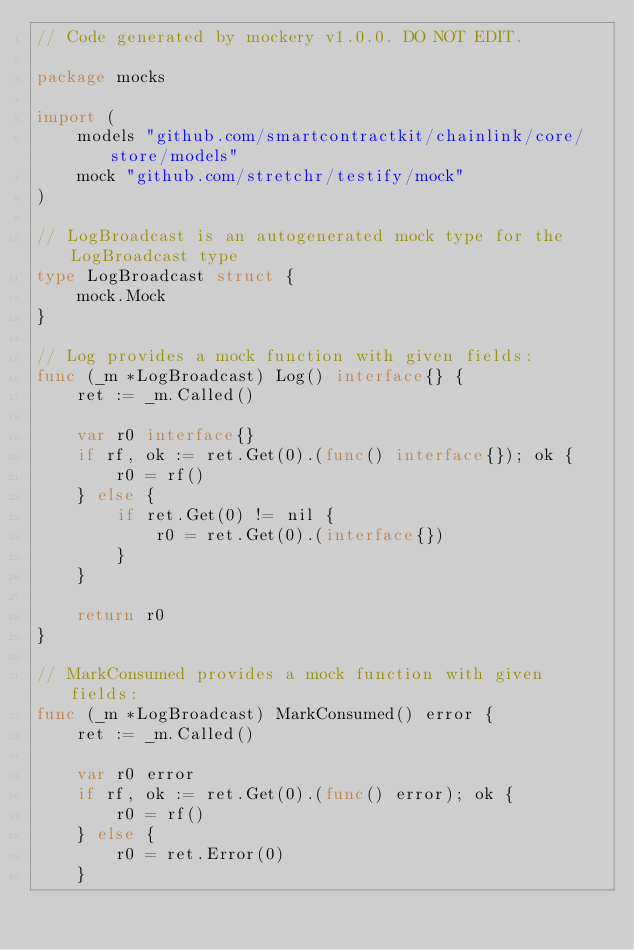<code> <loc_0><loc_0><loc_500><loc_500><_Go_>// Code generated by mockery v1.0.0. DO NOT EDIT.

package mocks

import (
	models "github.com/smartcontractkit/chainlink/core/store/models"
	mock "github.com/stretchr/testify/mock"
)

// LogBroadcast is an autogenerated mock type for the LogBroadcast type
type LogBroadcast struct {
	mock.Mock
}

// Log provides a mock function with given fields:
func (_m *LogBroadcast) Log() interface{} {
	ret := _m.Called()

	var r0 interface{}
	if rf, ok := ret.Get(0).(func() interface{}); ok {
		r0 = rf()
	} else {
		if ret.Get(0) != nil {
			r0 = ret.Get(0).(interface{})
		}
	}

	return r0
}

// MarkConsumed provides a mock function with given fields:
func (_m *LogBroadcast) MarkConsumed() error {
	ret := _m.Called()

	var r0 error
	if rf, ok := ret.Get(0).(func() error); ok {
		r0 = rf()
	} else {
		r0 = ret.Error(0)
	}
</code> 